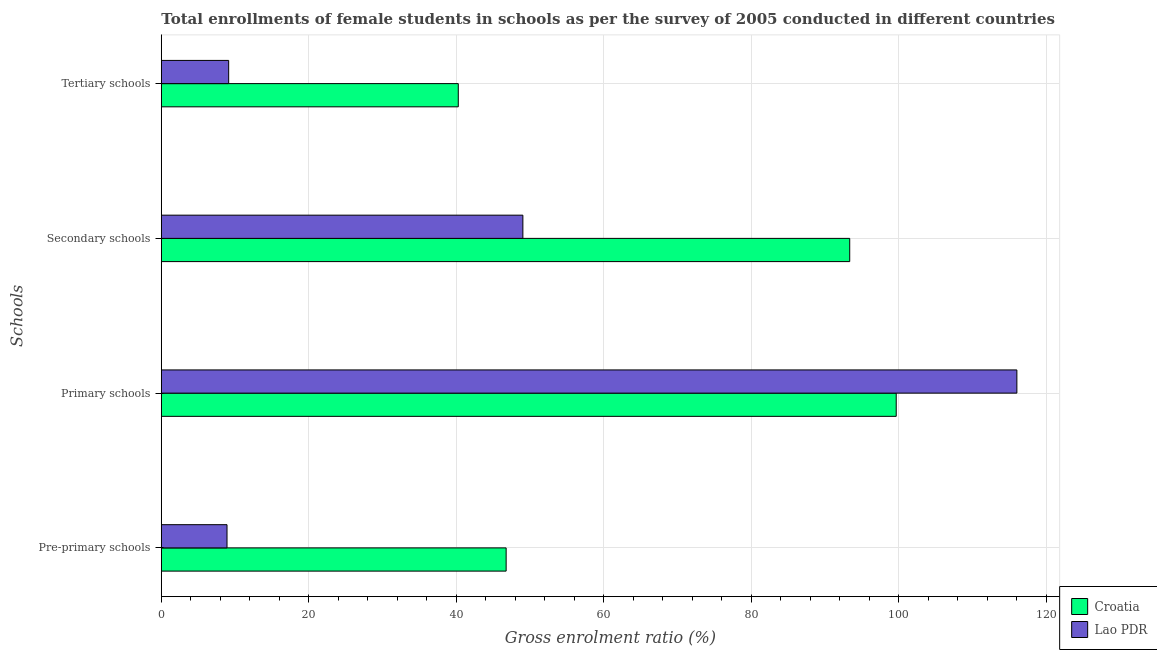How many groups of bars are there?
Keep it short and to the point. 4. Are the number of bars per tick equal to the number of legend labels?
Your answer should be very brief. Yes. Are the number of bars on each tick of the Y-axis equal?
Offer a terse response. Yes. How many bars are there on the 4th tick from the bottom?
Give a very brief answer. 2. What is the label of the 3rd group of bars from the top?
Make the answer very short. Primary schools. What is the gross enrolment ratio(female) in primary schools in Croatia?
Your response must be concise. 99.63. Across all countries, what is the maximum gross enrolment ratio(female) in secondary schools?
Offer a terse response. 93.33. Across all countries, what is the minimum gross enrolment ratio(female) in secondary schools?
Provide a succinct answer. 49.02. In which country was the gross enrolment ratio(female) in pre-primary schools maximum?
Your answer should be very brief. Croatia. In which country was the gross enrolment ratio(female) in pre-primary schools minimum?
Ensure brevity in your answer.  Lao PDR. What is the total gross enrolment ratio(female) in tertiary schools in the graph?
Give a very brief answer. 49.39. What is the difference between the gross enrolment ratio(female) in secondary schools in Croatia and that in Lao PDR?
Keep it short and to the point. 44.31. What is the difference between the gross enrolment ratio(female) in primary schools in Croatia and the gross enrolment ratio(female) in tertiary schools in Lao PDR?
Give a very brief answer. 90.5. What is the average gross enrolment ratio(female) in pre-primary schools per country?
Offer a terse response. 27.83. What is the difference between the gross enrolment ratio(female) in pre-primary schools and gross enrolment ratio(female) in tertiary schools in Croatia?
Provide a short and direct response. 6.49. In how many countries, is the gross enrolment ratio(female) in tertiary schools greater than 116 %?
Offer a terse response. 0. What is the ratio of the gross enrolment ratio(female) in secondary schools in Croatia to that in Lao PDR?
Make the answer very short. 1.9. What is the difference between the highest and the second highest gross enrolment ratio(female) in primary schools?
Your answer should be compact. 16.36. What is the difference between the highest and the lowest gross enrolment ratio(female) in tertiary schools?
Provide a succinct answer. 31.13. Is it the case that in every country, the sum of the gross enrolment ratio(female) in tertiary schools and gross enrolment ratio(female) in primary schools is greater than the sum of gross enrolment ratio(female) in pre-primary schools and gross enrolment ratio(female) in secondary schools?
Keep it short and to the point. No. What does the 1st bar from the top in Secondary schools represents?
Provide a succinct answer. Lao PDR. What does the 1st bar from the bottom in Primary schools represents?
Provide a short and direct response. Croatia. How many bars are there?
Ensure brevity in your answer.  8. How many countries are there in the graph?
Provide a short and direct response. 2. Are the values on the major ticks of X-axis written in scientific E-notation?
Keep it short and to the point. No. How many legend labels are there?
Give a very brief answer. 2. How are the legend labels stacked?
Offer a very short reply. Vertical. What is the title of the graph?
Offer a terse response. Total enrollments of female students in schools as per the survey of 2005 conducted in different countries. Does "Macedonia" appear as one of the legend labels in the graph?
Provide a succinct answer. No. What is the label or title of the X-axis?
Offer a terse response. Gross enrolment ratio (%). What is the label or title of the Y-axis?
Give a very brief answer. Schools. What is the Gross enrolment ratio (%) of Croatia in Pre-primary schools?
Your answer should be very brief. 46.75. What is the Gross enrolment ratio (%) in Lao PDR in Pre-primary schools?
Ensure brevity in your answer.  8.91. What is the Gross enrolment ratio (%) of Croatia in Primary schools?
Your answer should be very brief. 99.63. What is the Gross enrolment ratio (%) of Lao PDR in Primary schools?
Ensure brevity in your answer.  115.99. What is the Gross enrolment ratio (%) in Croatia in Secondary schools?
Your response must be concise. 93.33. What is the Gross enrolment ratio (%) in Lao PDR in Secondary schools?
Your answer should be very brief. 49.02. What is the Gross enrolment ratio (%) in Croatia in Tertiary schools?
Your answer should be very brief. 40.26. What is the Gross enrolment ratio (%) in Lao PDR in Tertiary schools?
Provide a short and direct response. 9.13. Across all Schools, what is the maximum Gross enrolment ratio (%) in Croatia?
Provide a short and direct response. 99.63. Across all Schools, what is the maximum Gross enrolment ratio (%) in Lao PDR?
Provide a succinct answer. 115.99. Across all Schools, what is the minimum Gross enrolment ratio (%) of Croatia?
Give a very brief answer. 40.26. Across all Schools, what is the minimum Gross enrolment ratio (%) of Lao PDR?
Make the answer very short. 8.91. What is the total Gross enrolment ratio (%) in Croatia in the graph?
Offer a very short reply. 279.97. What is the total Gross enrolment ratio (%) of Lao PDR in the graph?
Your answer should be compact. 183.05. What is the difference between the Gross enrolment ratio (%) in Croatia in Pre-primary schools and that in Primary schools?
Offer a terse response. -52.89. What is the difference between the Gross enrolment ratio (%) in Lao PDR in Pre-primary schools and that in Primary schools?
Your answer should be very brief. -107.09. What is the difference between the Gross enrolment ratio (%) of Croatia in Pre-primary schools and that in Secondary schools?
Your answer should be very brief. -46.58. What is the difference between the Gross enrolment ratio (%) in Lao PDR in Pre-primary schools and that in Secondary schools?
Your answer should be compact. -40.11. What is the difference between the Gross enrolment ratio (%) in Croatia in Pre-primary schools and that in Tertiary schools?
Ensure brevity in your answer.  6.49. What is the difference between the Gross enrolment ratio (%) of Lao PDR in Pre-primary schools and that in Tertiary schools?
Your response must be concise. -0.23. What is the difference between the Gross enrolment ratio (%) of Croatia in Primary schools and that in Secondary schools?
Provide a succinct answer. 6.3. What is the difference between the Gross enrolment ratio (%) of Lao PDR in Primary schools and that in Secondary schools?
Provide a succinct answer. 66.97. What is the difference between the Gross enrolment ratio (%) in Croatia in Primary schools and that in Tertiary schools?
Your answer should be very brief. 59.37. What is the difference between the Gross enrolment ratio (%) in Lao PDR in Primary schools and that in Tertiary schools?
Offer a very short reply. 106.86. What is the difference between the Gross enrolment ratio (%) in Croatia in Secondary schools and that in Tertiary schools?
Keep it short and to the point. 53.07. What is the difference between the Gross enrolment ratio (%) of Lao PDR in Secondary schools and that in Tertiary schools?
Your answer should be very brief. 39.89. What is the difference between the Gross enrolment ratio (%) in Croatia in Pre-primary schools and the Gross enrolment ratio (%) in Lao PDR in Primary schools?
Make the answer very short. -69.24. What is the difference between the Gross enrolment ratio (%) of Croatia in Pre-primary schools and the Gross enrolment ratio (%) of Lao PDR in Secondary schools?
Ensure brevity in your answer.  -2.27. What is the difference between the Gross enrolment ratio (%) in Croatia in Pre-primary schools and the Gross enrolment ratio (%) in Lao PDR in Tertiary schools?
Your answer should be compact. 37.62. What is the difference between the Gross enrolment ratio (%) in Croatia in Primary schools and the Gross enrolment ratio (%) in Lao PDR in Secondary schools?
Keep it short and to the point. 50.62. What is the difference between the Gross enrolment ratio (%) in Croatia in Primary schools and the Gross enrolment ratio (%) in Lao PDR in Tertiary schools?
Ensure brevity in your answer.  90.5. What is the difference between the Gross enrolment ratio (%) of Croatia in Secondary schools and the Gross enrolment ratio (%) of Lao PDR in Tertiary schools?
Ensure brevity in your answer.  84.2. What is the average Gross enrolment ratio (%) in Croatia per Schools?
Provide a succinct answer. 69.99. What is the average Gross enrolment ratio (%) of Lao PDR per Schools?
Offer a terse response. 45.76. What is the difference between the Gross enrolment ratio (%) of Croatia and Gross enrolment ratio (%) of Lao PDR in Pre-primary schools?
Provide a short and direct response. 37.84. What is the difference between the Gross enrolment ratio (%) in Croatia and Gross enrolment ratio (%) in Lao PDR in Primary schools?
Give a very brief answer. -16.36. What is the difference between the Gross enrolment ratio (%) in Croatia and Gross enrolment ratio (%) in Lao PDR in Secondary schools?
Your response must be concise. 44.31. What is the difference between the Gross enrolment ratio (%) of Croatia and Gross enrolment ratio (%) of Lao PDR in Tertiary schools?
Give a very brief answer. 31.13. What is the ratio of the Gross enrolment ratio (%) of Croatia in Pre-primary schools to that in Primary schools?
Provide a succinct answer. 0.47. What is the ratio of the Gross enrolment ratio (%) in Lao PDR in Pre-primary schools to that in Primary schools?
Keep it short and to the point. 0.08. What is the ratio of the Gross enrolment ratio (%) in Croatia in Pre-primary schools to that in Secondary schools?
Offer a very short reply. 0.5. What is the ratio of the Gross enrolment ratio (%) of Lao PDR in Pre-primary schools to that in Secondary schools?
Keep it short and to the point. 0.18. What is the ratio of the Gross enrolment ratio (%) of Croatia in Pre-primary schools to that in Tertiary schools?
Keep it short and to the point. 1.16. What is the ratio of the Gross enrolment ratio (%) of Lao PDR in Pre-primary schools to that in Tertiary schools?
Your answer should be compact. 0.98. What is the ratio of the Gross enrolment ratio (%) of Croatia in Primary schools to that in Secondary schools?
Offer a very short reply. 1.07. What is the ratio of the Gross enrolment ratio (%) in Lao PDR in Primary schools to that in Secondary schools?
Ensure brevity in your answer.  2.37. What is the ratio of the Gross enrolment ratio (%) in Croatia in Primary schools to that in Tertiary schools?
Offer a terse response. 2.47. What is the ratio of the Gross enrolment ratio (%) in Lao PDR in Primary schools to that in Tertiary schools?
Make the answer very short. 12.7. What is the ratio of the Gross enrolment ratio (%) of Croatia in Secondary schools to that in Tertiary schools?
Keep it short and to the point. 2.32. What is the ratio of the Gross enrolment ratio (%) of Lao PDR in Secondary schools to that in Tertiary schools?
Your answer should be compact. 5.37. What is the difference between the highest and the second highest Gross enrolment ratio (%) in Croatia?
Ensure brevity in your answer.  6.3. What is the difference between the highest and the second highest Gross enrolment ratio (%) of Lao PDR?
Provide a succinct answer. 66.97. What is the difference between the highest and the lowest Gross enrolment ratio (%) of Croatia?
Your response must be concise. 59.37. What is the difference between the highest and the lowest Gross enrolment ratio (%) of Lao PDR?
Your response must be concise. 107.09. 